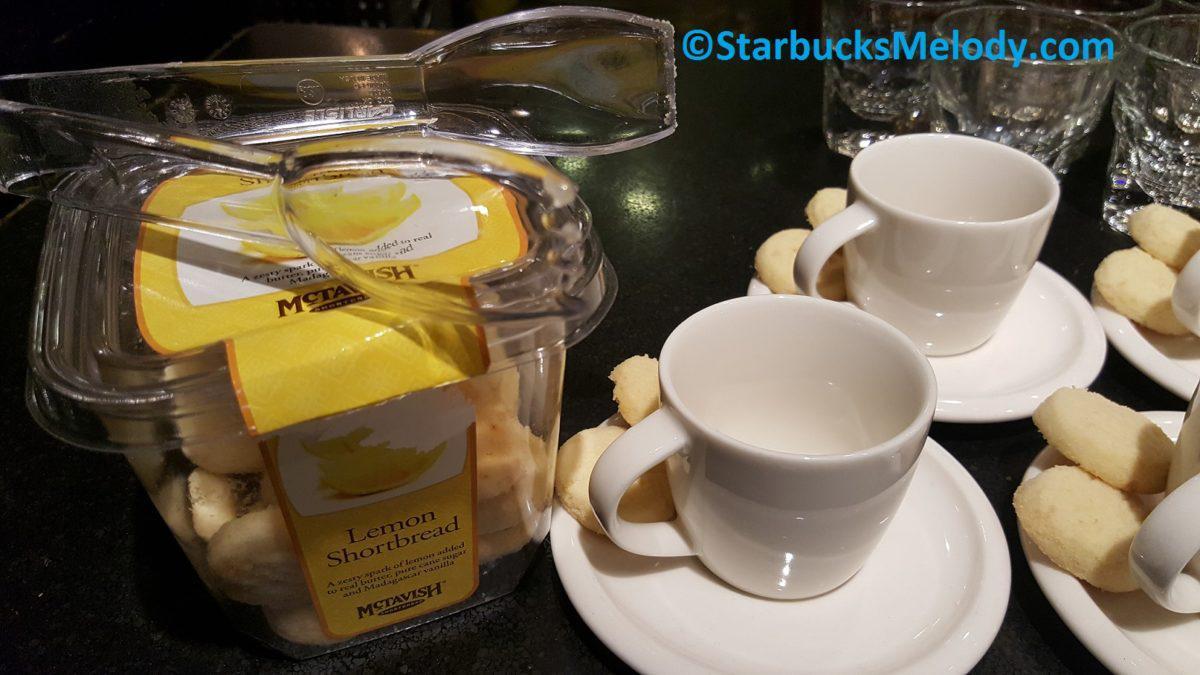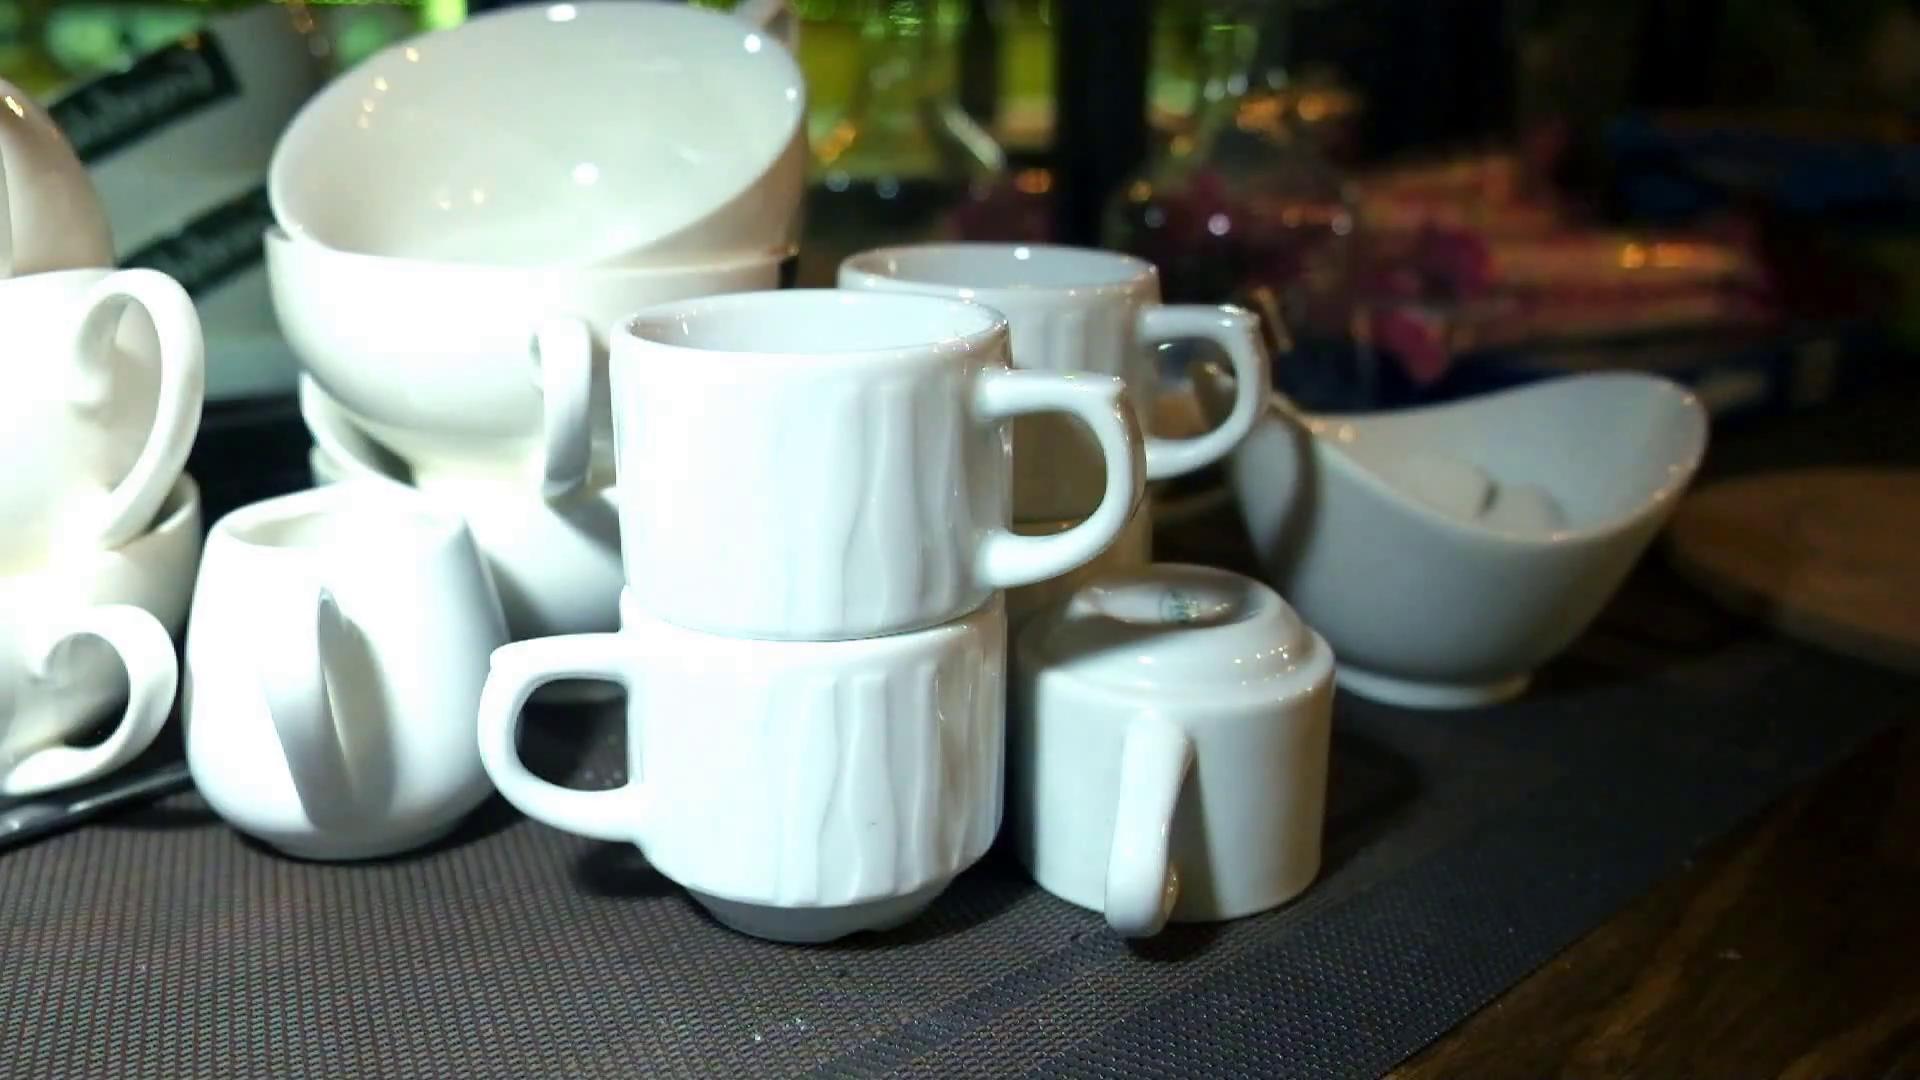The first image is the image on the left, the second image is the image on the right. Given the left and right images, does the statement "In at least one image there is a single white cup of coffee on a plate that is all sitting on brown wooden table." hold true? Answer yes or no. No. The first image is the image on the left, the second image is the image on the right. Examine the images to the left and right. Is the description "All the cups are solid white." accurate? Answer yes or no. Yes. 